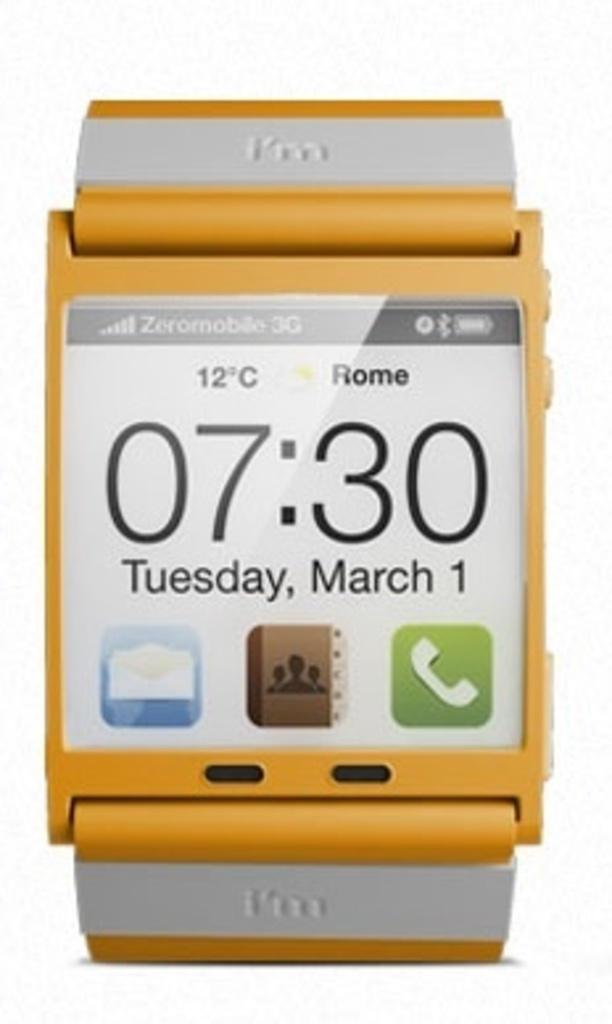<image>
Describe the image concisely. A yellow I'm watch shows the date as Thursday, March 1 